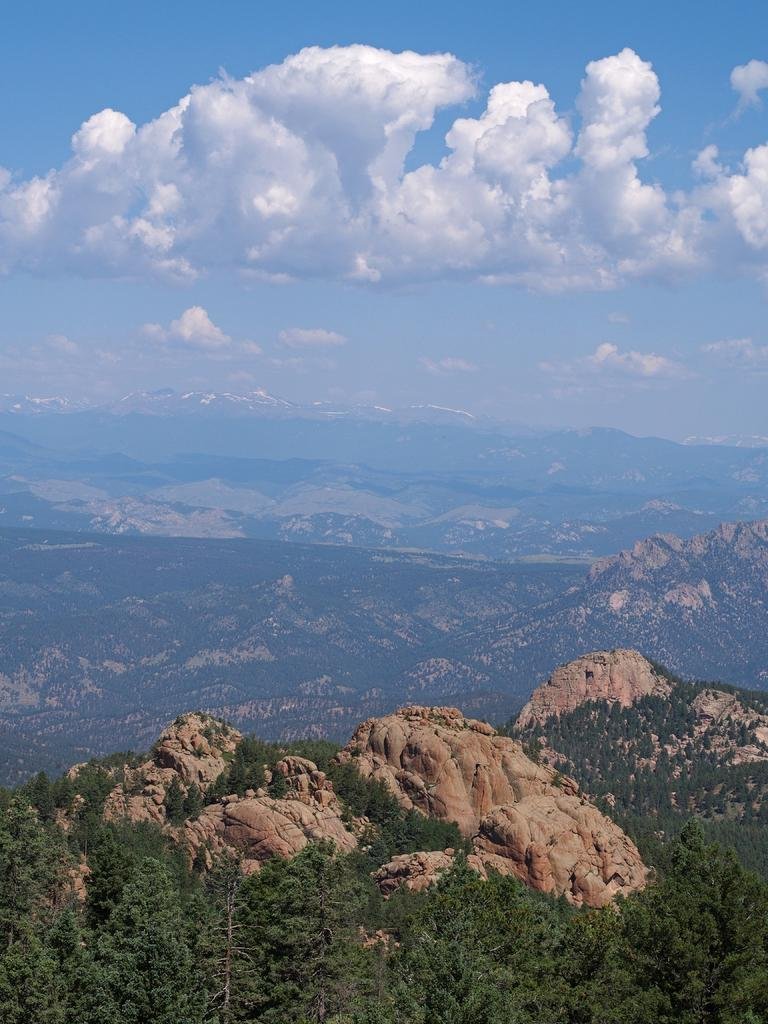What type of natural features can be seen in the image? There are trees, rocks, and mountains in the image. What is visible in the background of the image? The sky is visible in the background of the image. What can be seen in the sky? Clouds are present in the sky. What type of pot is being offered to the mountains in the image? There is no pot or offering present in the image; it features natural landscapes with trees, rocks, and mountains. 